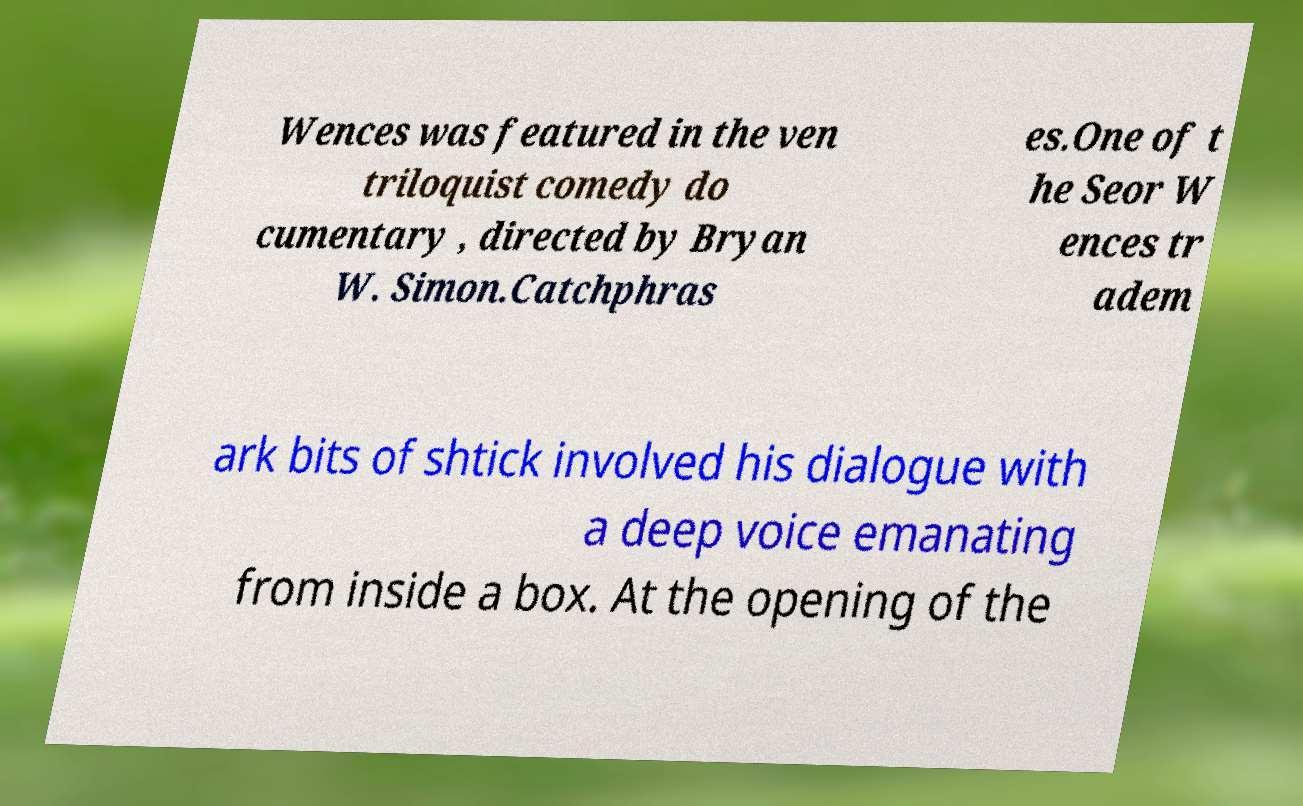Please read and relay the text visible in this image. What does it say? Wences was featured in the ven triloquist comedy do cumentary , directed by Bryan W. Simon.Catchphras es.One of t he Seor W ences tr adem ark bits of shtick involved his dialogue with a deep voice emanating from inside a box. At the opening of the 